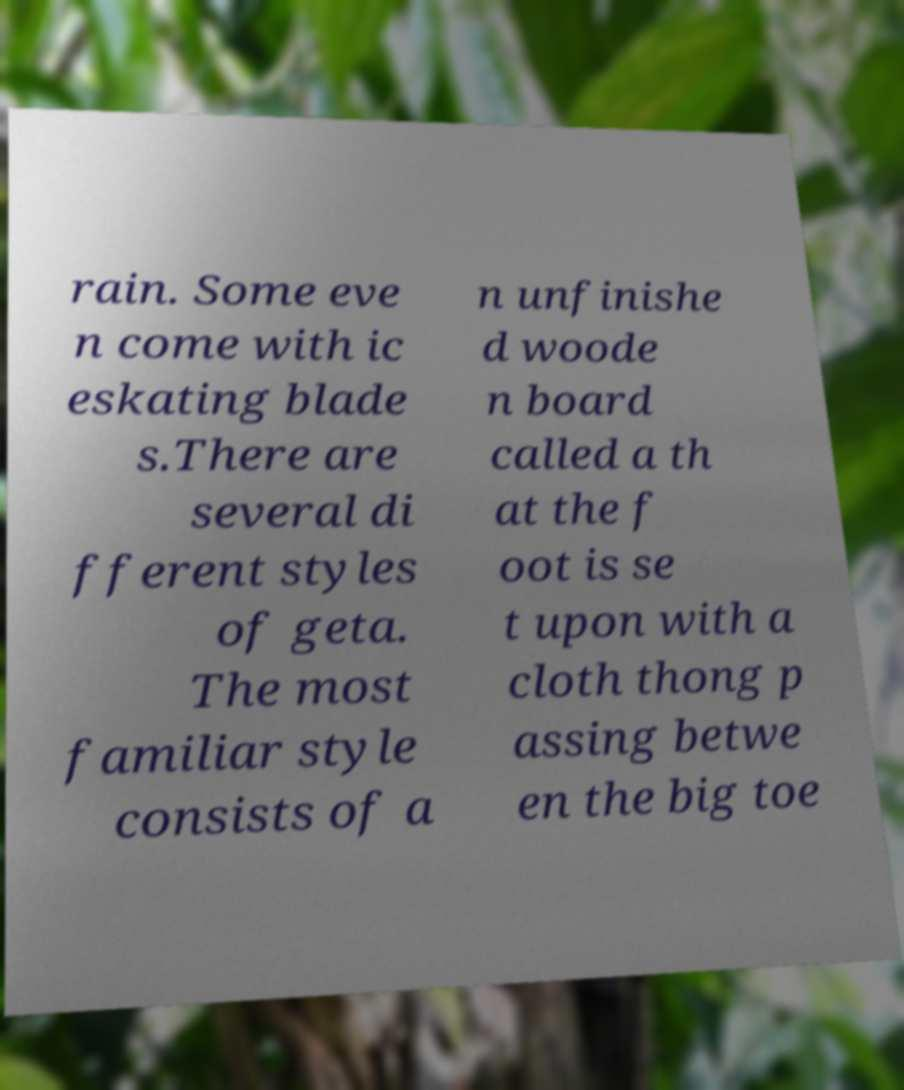There's text embedded in this image that I need extracted. Can you transcribe it verbatim? rain. Some eve n come with ic eskating blade s.There are several di fferent styles of geta. The most familiar style consists of a n unfinishe d woode n board called a th at the f oot is se t upon with a cloth thong p assing betwe en the big toe 